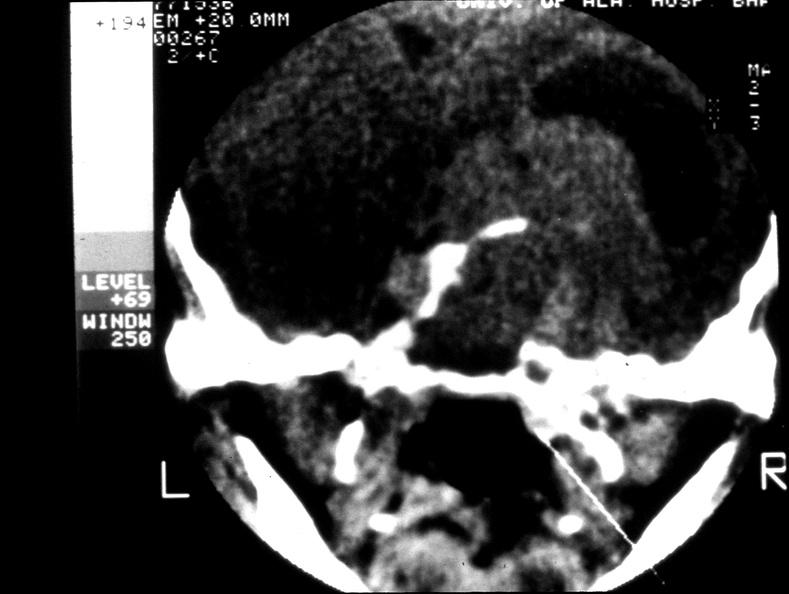s endocrine present?
Answer the question using a single word or phrase. Yes 